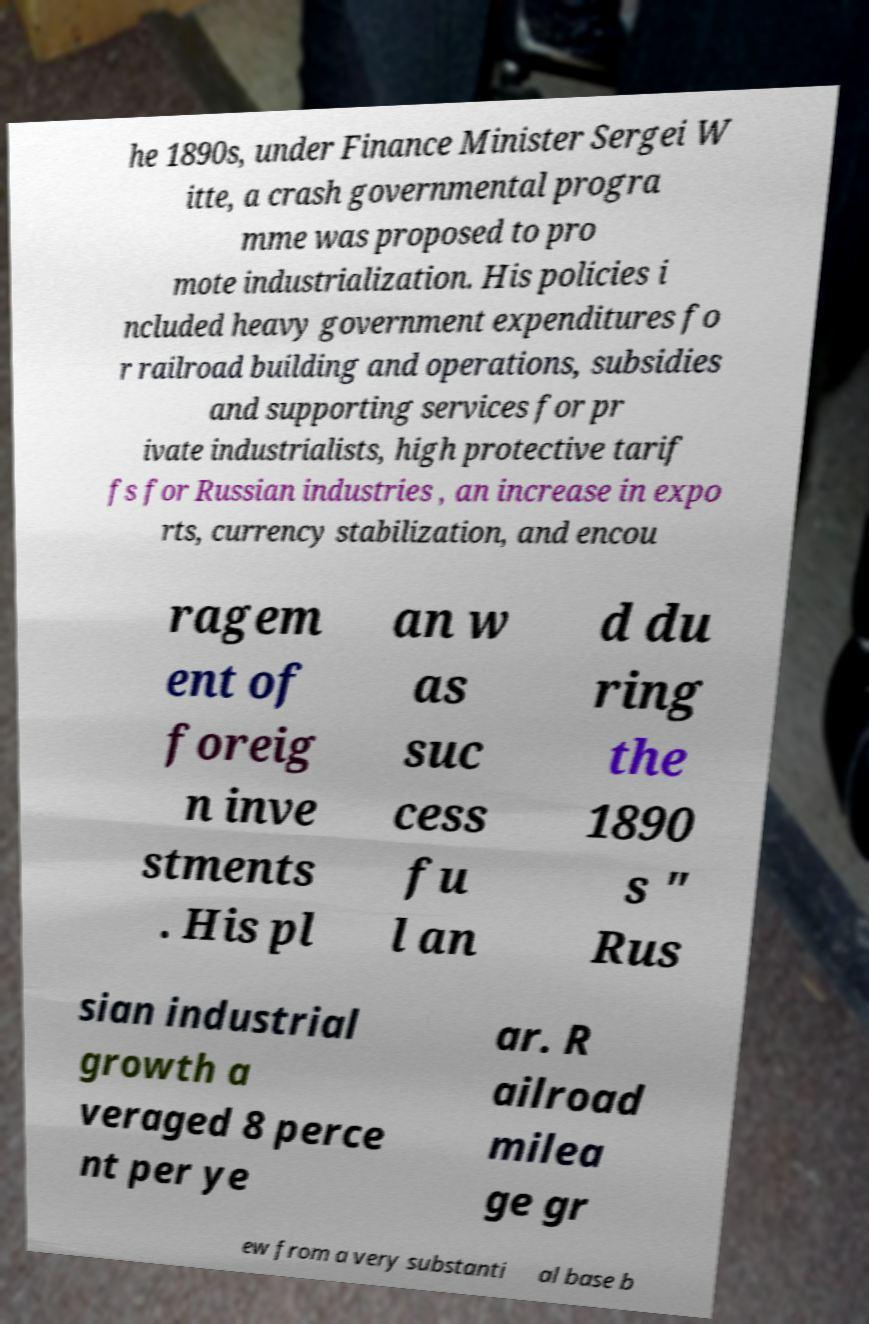Could you assist in decoding the text presented in this image and type it out clearly? he 1890s, under Finance Minister Sergei W itte, a crash governmental progra mme was proposed to pro mote industrialization. His policies i ncluded heavy government expenditures fo r railroad building and operations, subsidies and supporting services for pr ivate industrialists, high protective tarif fs for Russian industries , an increase in expo rts, currency stabilization, and encou ragem ent of foreig n inve stments . His pl an w as suc cess fu l an d du ring the 1890 s " Rus sian industrial growth a veraged 8 perce nt per ye ar. R ailroad milea ge gr ew from a very substanti al base b 